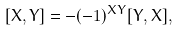Convert formula to latex. <formula><loc_0><loc_0><loc_500><loc_500>[ X , Y ] = - ( - 1 ) ^ { X Y } [ Y , X ] ,</formula> 